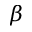<formula> <loc_0><loc_0><loc_500><loc_500>\beta</formula> 